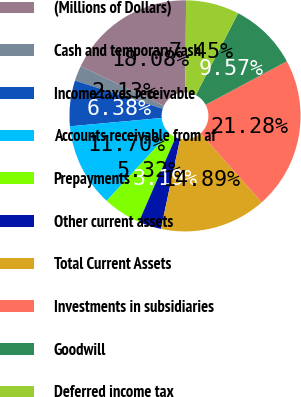Convert chart to OTSL. <chart><loc_0><loc_0><loc_500><loc_500><pie_chart><fcel>(Millions of Dollars)<fcel>Cash and temporary cash<fcel>Income taxes receivable<fcel>Accounts receivable from af<fcel>Prepayments<fcel>Other current assets<fcel>Total Current Assets<fcel>Investments in subsidiaries<fcel>Goodwill<fcel>Deferred income tax<nl><fcel>18.08%<fcel>2.13%<fcel>6.38%<fcel>11.7%<fcel>5.32%<fcel>3.19%<fcel>14.89%<fcel>21.28%<fcel>9.57%<fcel>7.45%<nl></chart> 